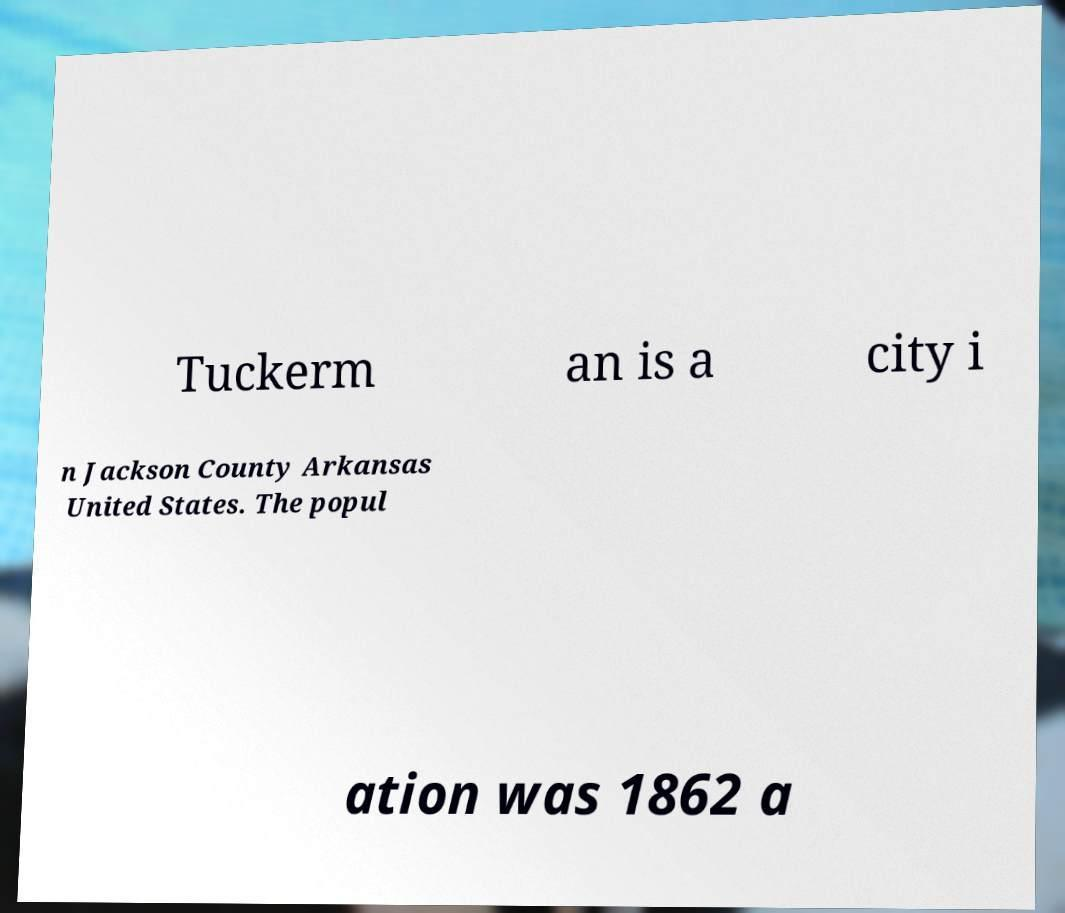Can you accurately transcribe the text from the provided image for me? Tuckerm an is a city i n Jackson County Arkansas United States. The popul ation was 1862 a 